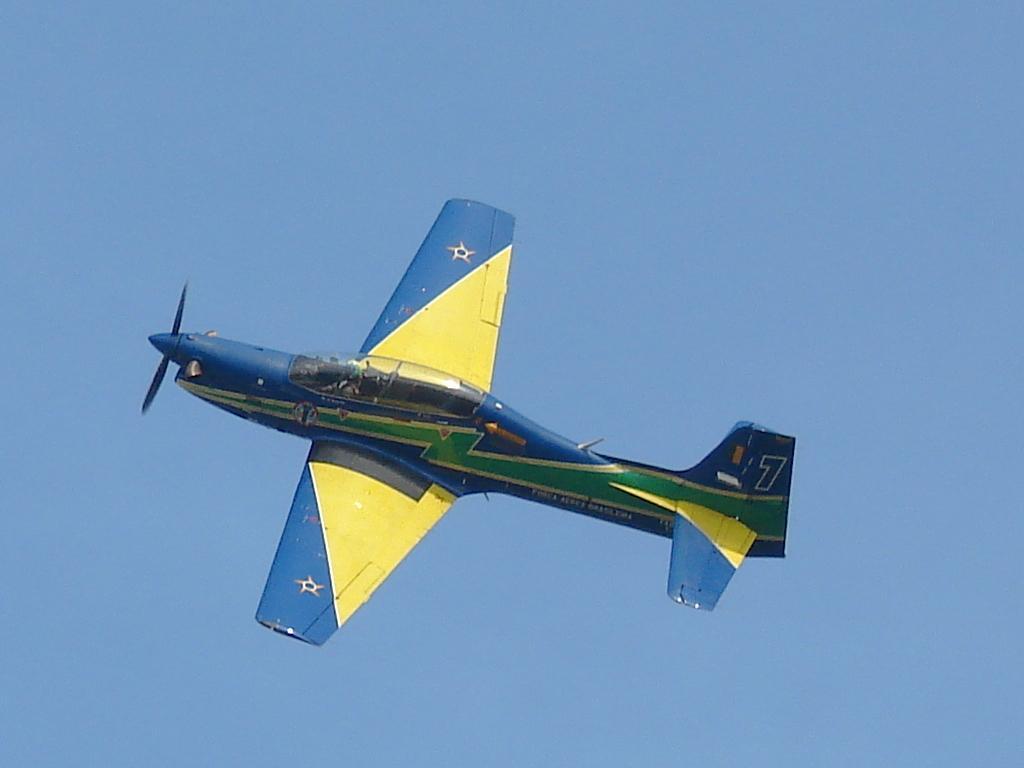Can you describe this image briefly? In this picture I can see an aircraft in the sky. 